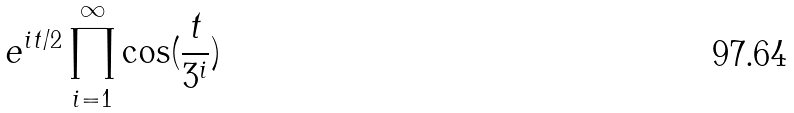Convert formula to latex. <formula><loc_0><loc_0><loc_500><loc_500>e ^ { i t / 2 } \prod _ { i = 1 } ^ { \infty } \cos ( \frac { t } { 3 ^ { i } } )</formula> 